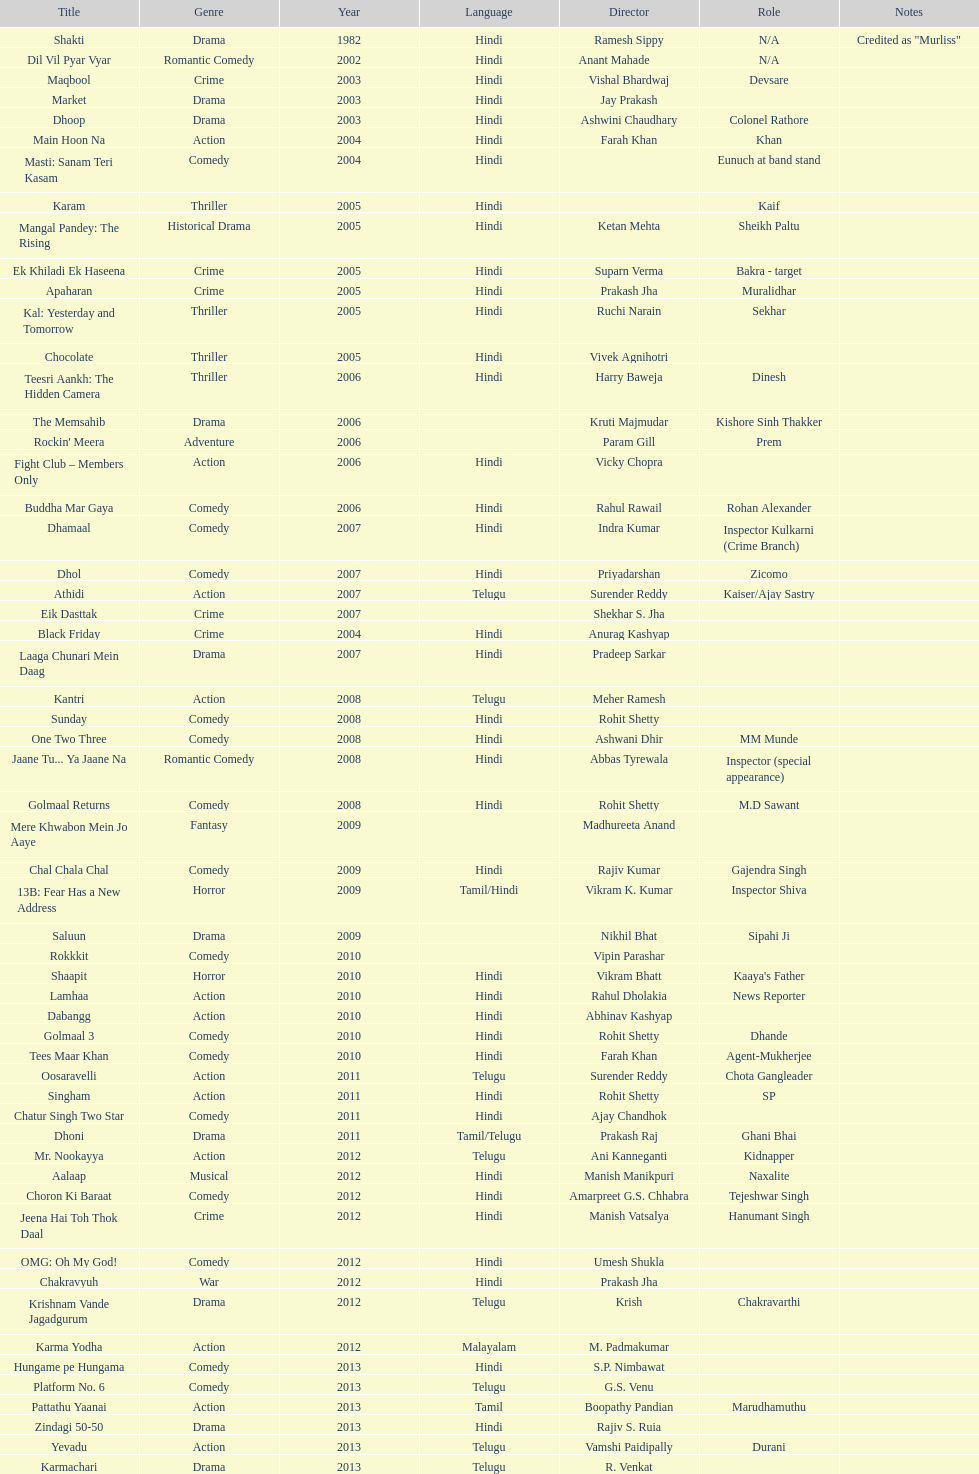What title is before dhol in 2007? Dhamaal. 